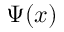<formula> <loc_0><loc_0><loc_500><loc_500>\Psi ( x )</formula> 